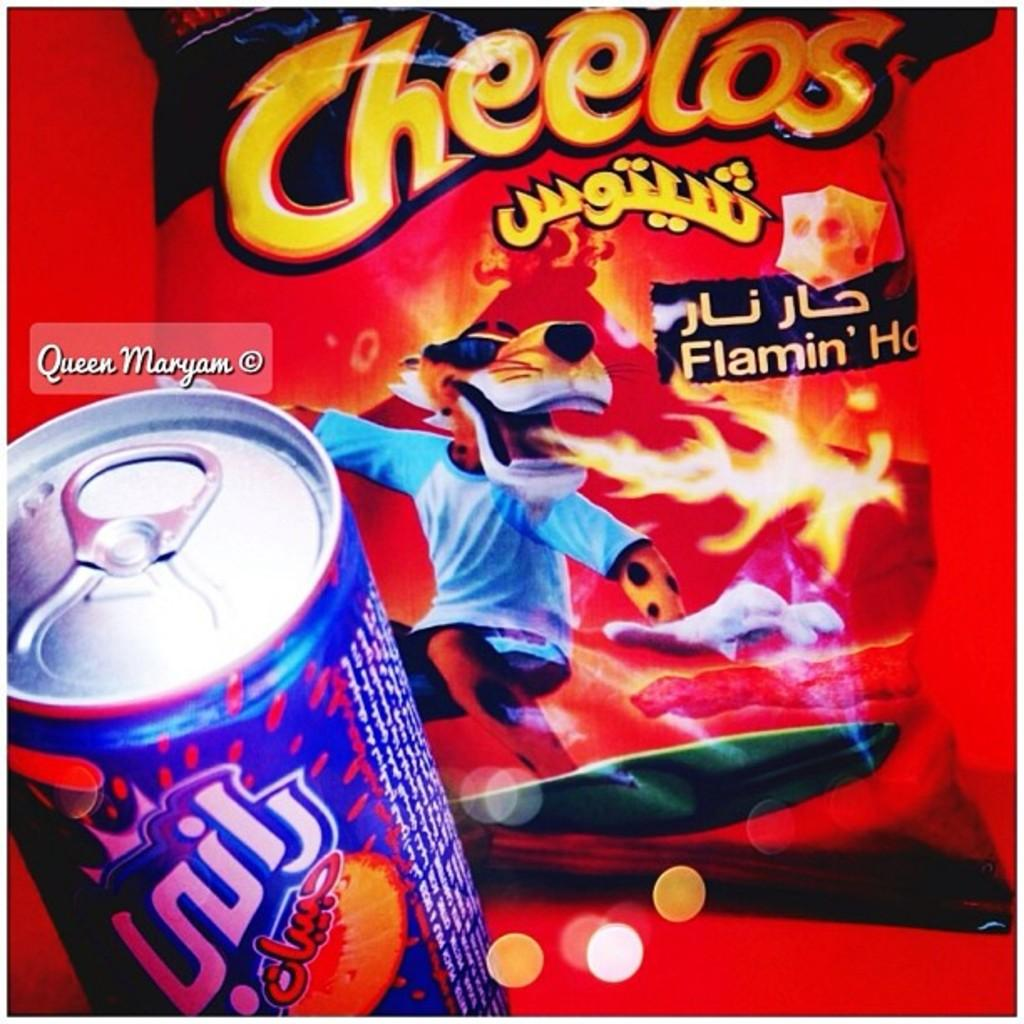<image>
Offer a succinct explanation of the picture presented. A blue can of drink sits in front of a bag of Cheetos. 